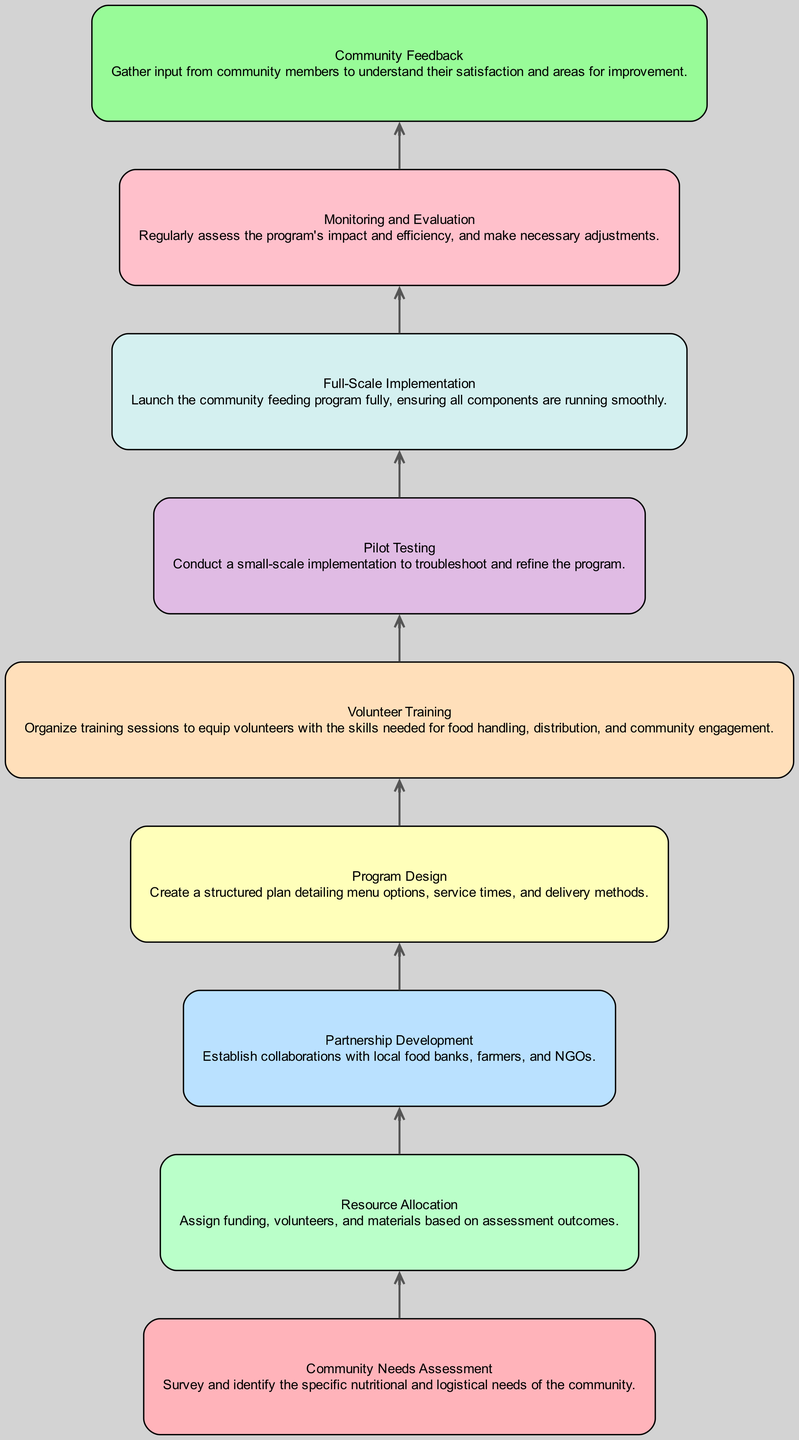What is the first step in the process? The diagram indicates that the first step is "Community Needs Assessment," which is foundational for identifying the specific needs of the community before any further action.
Answer: Community Needs Assessment How many nodes are there in total? The diagram lists a total of 9 distinct elements or nodes, each representing a different step in implementing the feeding program.
Answer: 9 What follows after "Resource Allocation"? Looking at the flow, "Partnership Development" immediately follows "Resource Allocation," indicating that after resources are allocated, partnerships are developed to enhance program implementation.
Answer: Partnership Development Which step requires "Volunteer Training" as a prerequisite? According to the diagram, "Pilot Testing" requires "Volunteer Training" to ensure that volunteers are adequately prepared before testing the program on a smaller scale.
Answer: Pilot Testing In which phase is "Community Feedback" gathered? The step "Community Feedback" is collected after "Monitoring and Evaluation," reflecting the importance of assessing the program's impact before soliciting community input for potential improvements.
Answer: Monitoring and Evaluation What is the final step in the community feeding program implementation? The last step in the process, as represented in the diagram, is "Community Feedback," emphasizing the need for continuous improvement based on user experience.
Answer: Community Feedback If training is not conducted, what would be the immediate consequence? Without completing "Volunteer Training," the next step "Pilot Testing" cannot occur since it is dependent on having trained volunteers ready for implementation.
Answer: Pilot Testing How does "Partnership Development" influence "Program Design"? "Partnership Development" is a prerequisite for "Program Design," meaning that successful collaboration with local resources directly impacts the planning of the feeding program's structure.
Answer: Program Design Which step is linked to the evaluation process? "Monitoring and Evaluation" is the step that deals with assessing the effectiveness and efficiency of the program throughout its implementation, ensuring feedback loops for adjustments.
Answer: Monitoring and Evaluation 